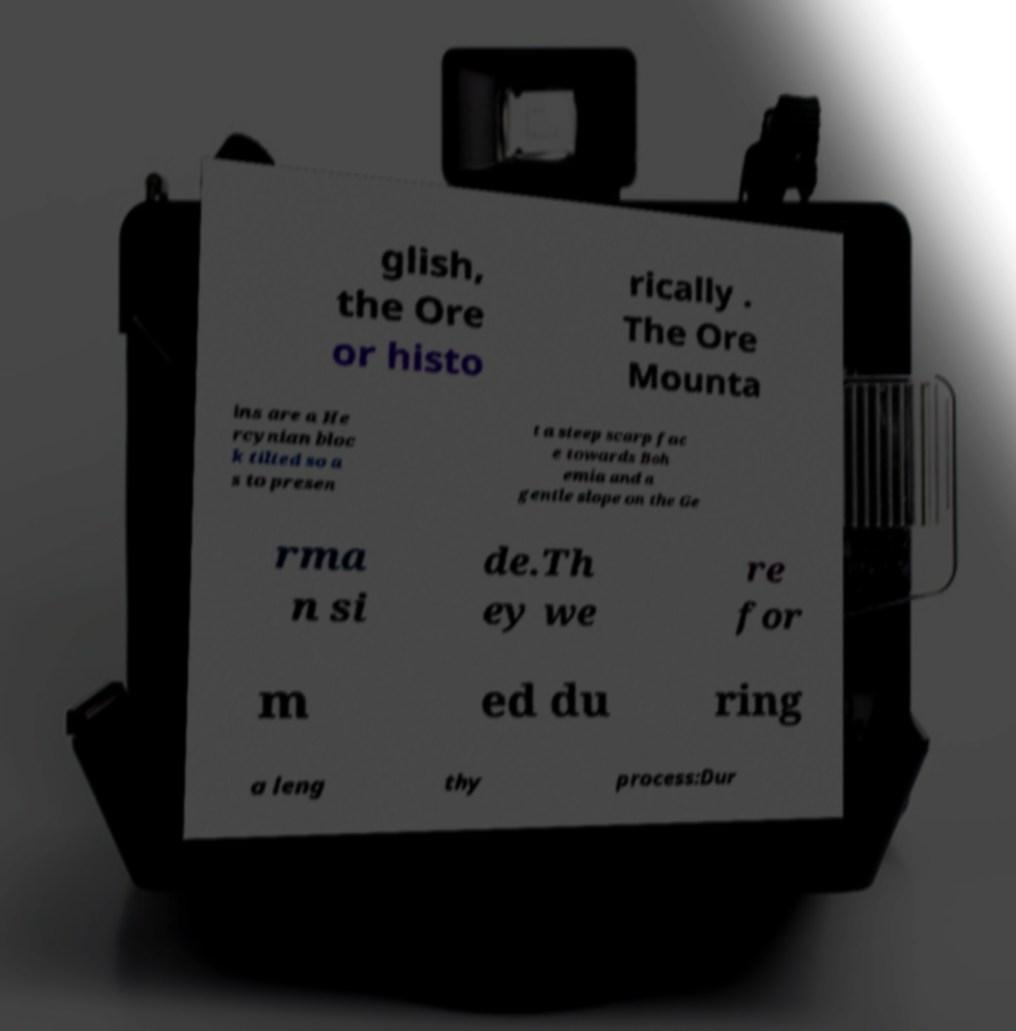Please read and relay the text visible in this image. What does it say? glish, the Ore or histo rically . The Ore Mounta ins are a He rcynian bloc k tilted so a s to presen t a steep scarp fac e towards Boh emia and a gentle slope on the Ge rma n si de.Th ey we re for m ed du ring a leng thy process:Dur 